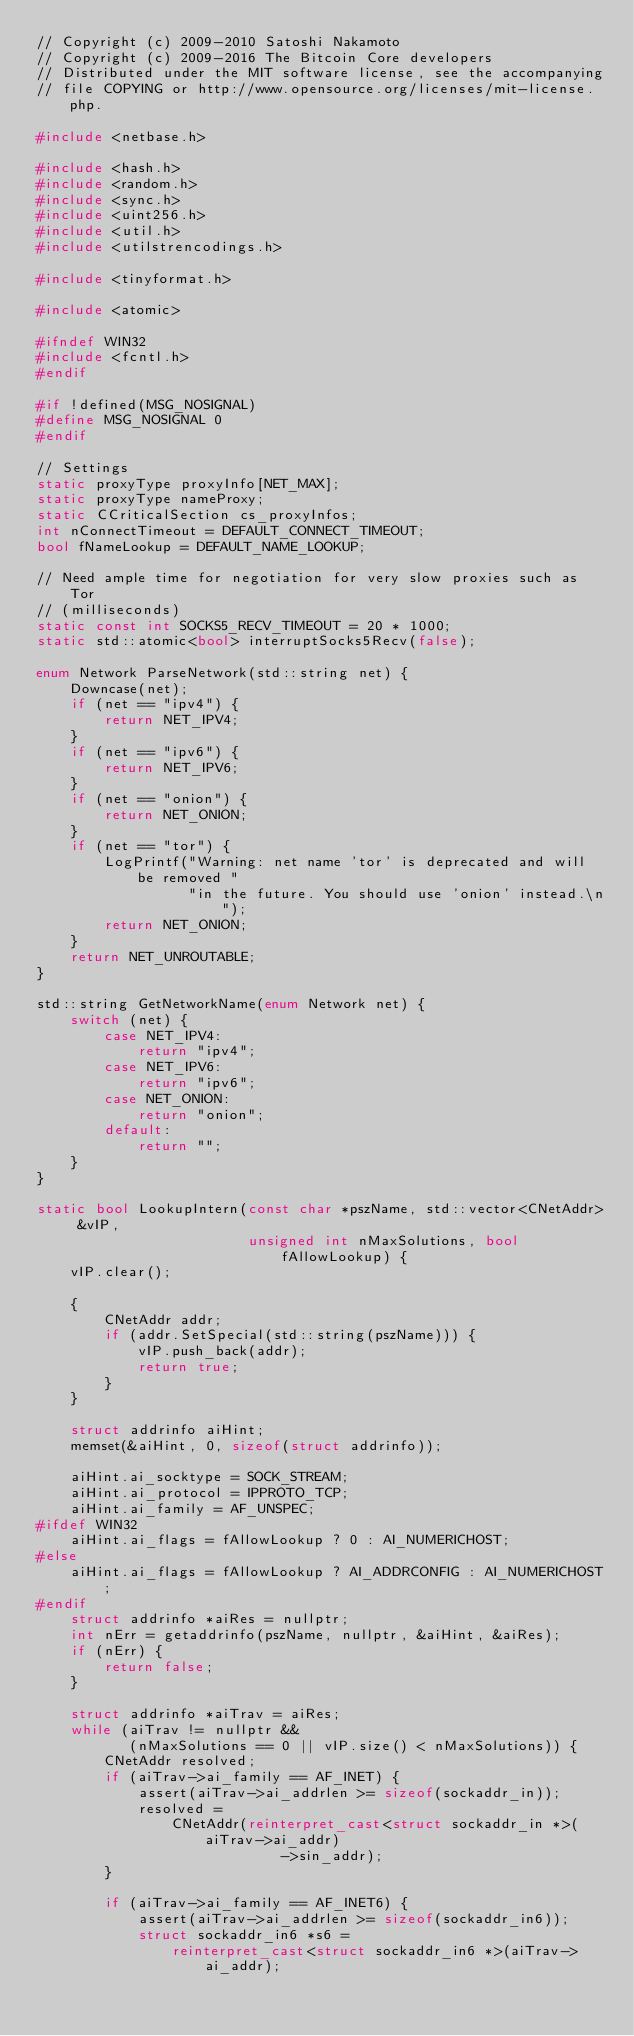Convert code to text. <code><loc_0><loc_0><loc_500><loc_500><_C++_>// Copyright (c) 2009-2010 Satoshi Nakamoto
// Copyright (c) 2009-2016 The Bitcoin Core developers
// Distributed under the MIT software license, see the accompanying
// file COPYING or http://www.opensource.org/licenses/mit-license.php.

#include <netbase.h>

#include <hash.h>
#include <random.h>
#include <sync.h>
#include <uint256.h>
#include <util.h>
#include <utilstrencodings.h>

#include <tinyformat.h>

#include <atomic>

#ifndef WIN32
#include <fcntl.h>
#endif

#if !defined(MSG_NOSIGNAL)
#define MSG_NOSIGNAL 0
#endif

// Settings
static proxyType proxyInfo[NET_MAX];
static proxyType nameProxy;
static CCriticalSection cs_proxyInfos;
int nConnectTimeout = DEFAULT_CONNECT_TIMEOUT;
bool fNameLookup = DEFAULT_NAME_LOOKUP;

// Need ample time for negotiation for very slow proxies such as Tor
// (milliseconds)
static const int SOCKS5_RECV_TIMEOUT = 20 * 1000;
static std::atomic<bool> interruptSocks5Recv(false);

enum Network ParseNetwork(std::string net) {
    Downcase(net);
    if (net == "ipv4") {
        return NET_IPV4;
    }
    if (net == "ipv6") {
        return NET_IPV6;
    }
    if (net == "onion") {
        return NET_ONION;
    }
    if (net == "tor") {
        LogPrintf("Warning: net name 'tor' is deprecated and will be removed "
                  "in the future. You should use 'onion' instead.\n");
        return NET_ONION;
    }
    return NET_UNROUTABLE;
}

std::string GetNetworkName(enum Network net) {
    switch (net) {
        case NET_IPV4:
            return "ipv4";
        case NET_IPV6:
            return "ipv6";
        case NET_ONION:
            return "onion";
        default:
            return "";
    }
}

static bool LookupIntern(const char *pszName, std::vector<CNetAddr> &vIP,
                         unsigned int nMaxSolutions, bool fAllowLookup) {
    vIP.clear();

    {
        CNetAddr addr;
        if (addr.SetSpecial(std::string(pszName))) {
            vIP.push_back(addr);
            return true;
        }
    }

    struct addrinfo aiHint;
    memset(&aiHint, 0, sizeof(struct addrinfo));

    aiHint.ai_socktype = SOCK_STREAM;
    aiHint.ai_protocol = IPPROTO_TCP;
    aiHint.ai_family = AF_UNSPEC;
#ifdef WIN32
    aiHint.ai_flags = fAllowLookup ? 0 : AI_NUMERICHOST;
#else
    aiHint.ai_flags = fAllowLookup ? AI_ADDRCONFIG : AI_NUMERICHOST;
#endif
    struct addrinfo *aiRes = nullptr;
    int nErr = getaddrinfo(pszName, nullptr, &aiHint, &aiRes);
    if (nErr) {
        return false;
    }

    struct addrinfo *aiTrav = aiRes;
    while (aiTrav != nullptr &&
           (nMaxSolutions == 0 || vIP.size() < nMaxSolutions)) {
        CNetAddr resolved;
        if (aiTrav->ai_family == AF_INET) {
            assert(aiTrav->ai_addrlen >= sizeof(sockaddr_in));
            resolved =
                CNetAddr(reinterpret_cast<struct sockaddr_in *>(aiTrav->ai_addr)
                             ->sin_addr);
        }

        if (aiTrav->ai_family == AF_INET6) {
            assert(aiTrav->ai_addrlen >= sizeof(sockaddr_in6));
            struct sockaddr_in6 *s6 =
                reinterpret_cast<struct sockaddr_in6 *>(aiTrav->ai_addr);</code> 